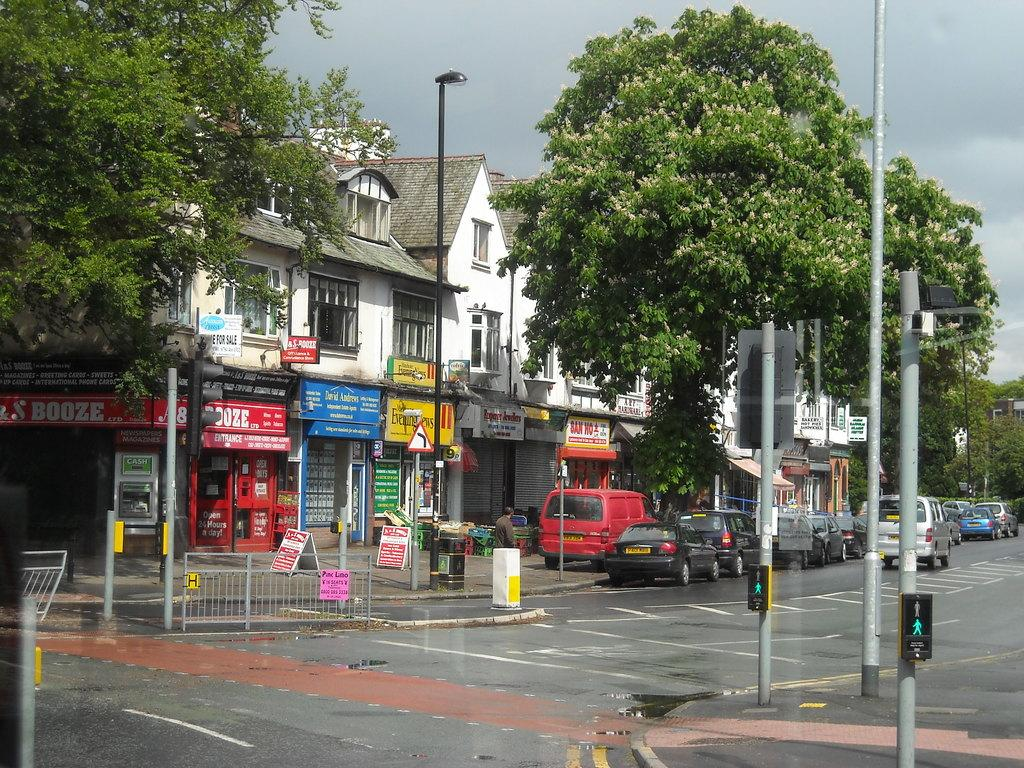<image>
Create a compact narrative representing the image presented. A street with a number of local business, including one that is called Evening News. 